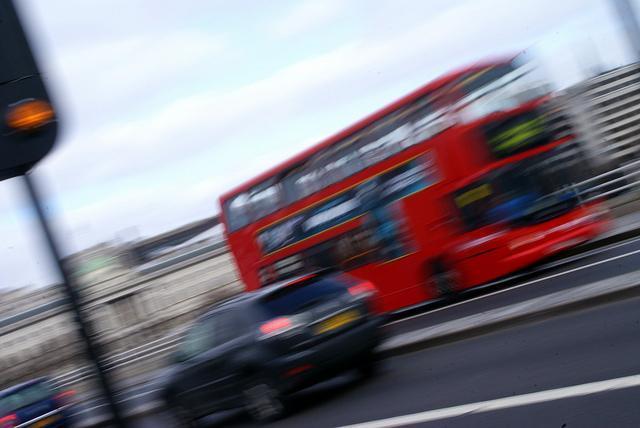How many cars can be seen?
Give a very brief answer. 2. How many buses are there?
Give a very brief answer. 1. How many people are wearing orange shirts?
Give a very brief answer. 0. 